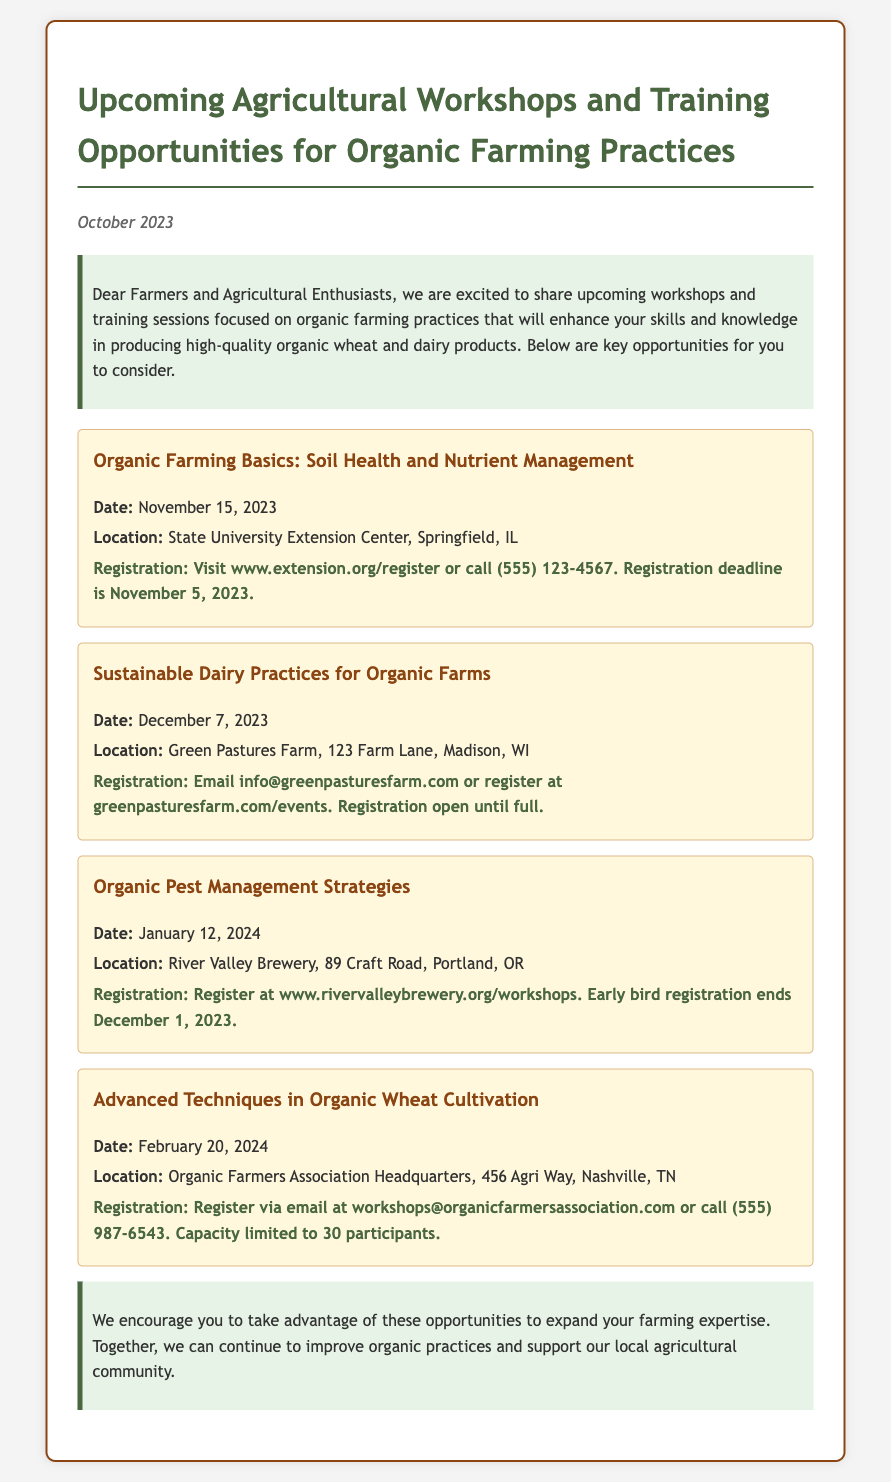What is the first workshop title? The title of the first workshop focused on organic farming practices as mentioned in the document.
Answer: Organic Farming Basics: Soil Health and Nutrient Management When is the registration deadline for the first workshop? The registration deadline is a specific date provided for the first workshop.
Answer: November 5, 2023 Where will the Sustainable Dairy Practices workshop be held? The location is specified in the document for the second workshop.
Answer: Green Pastures Farm, 123 Farm Lane, Madison, WI What is the date of the Organic Pest Management Strategies workshop? The date is provided within the details of the third workshop.
Answer: January 12, 2024 How can one register for the Advanced Techniques in Organic Wheat Cultivation workshop? The registration method is specified in detail for the last workshop.
Answer: Email at workshops@organicfarmersassociation.com or call (555) 987-6543 Which workshop has an early bird registration ending date? The question requires reasoning by identifying the workshop related to early bird registration.
Answer: Organic Pest Management Strategies What is the capacity limit for the Advanced Techniques in Organic Wheat Cultivation workshop? The capacity limit is a specific number provided for that workshop.
Answer: 30 participants What is the focus of the workshops mentioned in this memo? The question asks for an overarching theme or focus repeated throughout the document.
Answer: Organic farming practices 